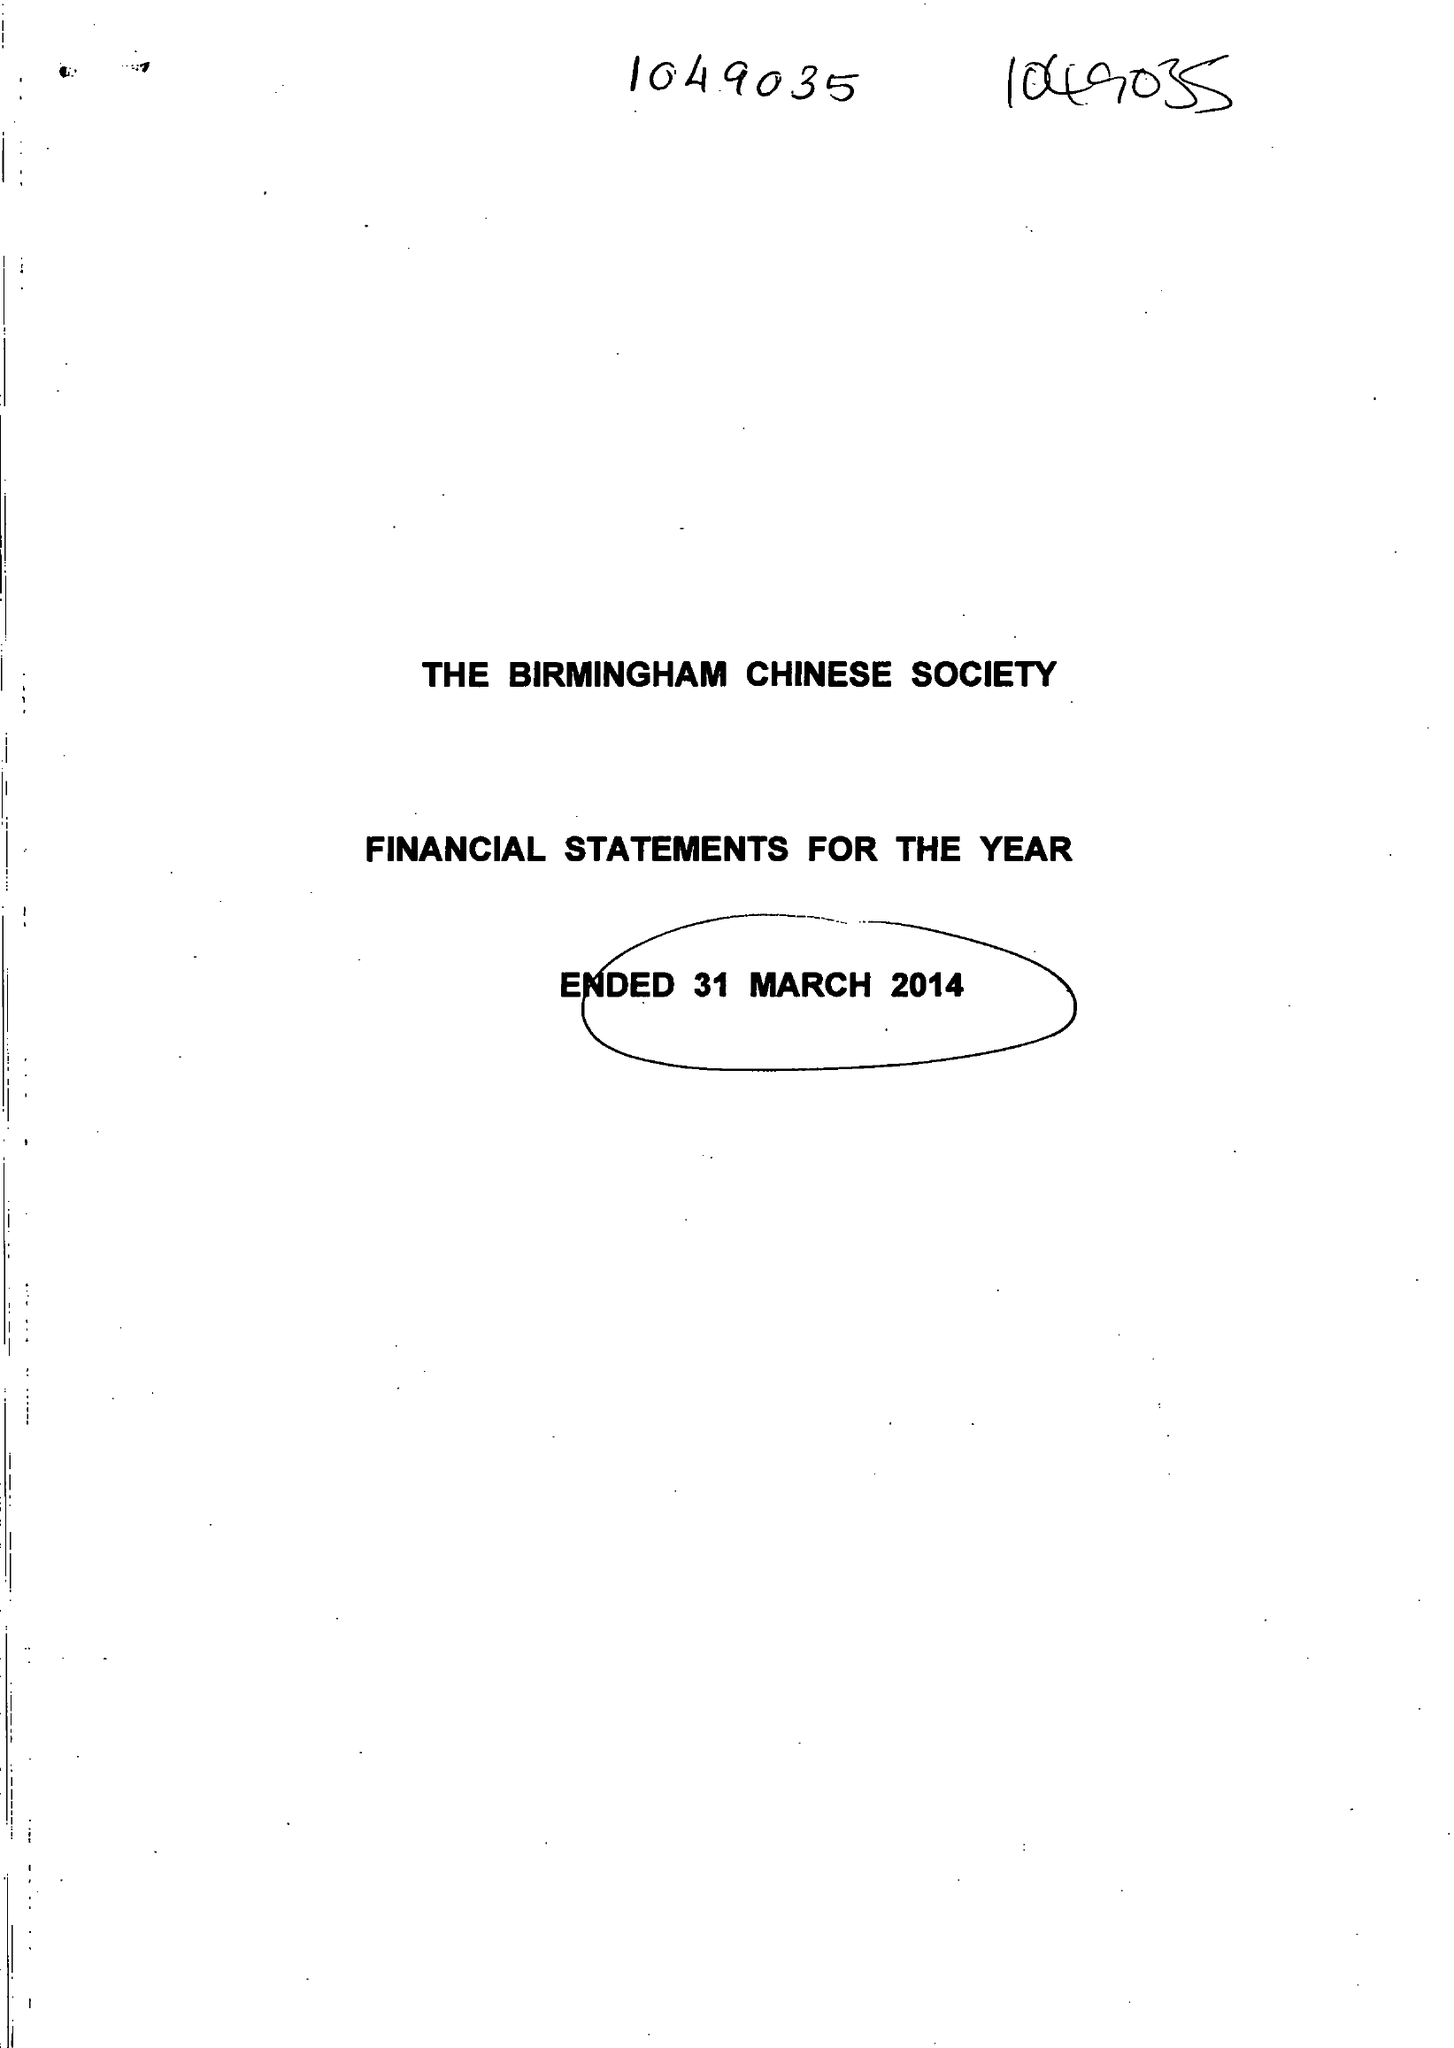What is the value for the address__postcode?
Answer the question using a single word or phrase. B9 4DY 